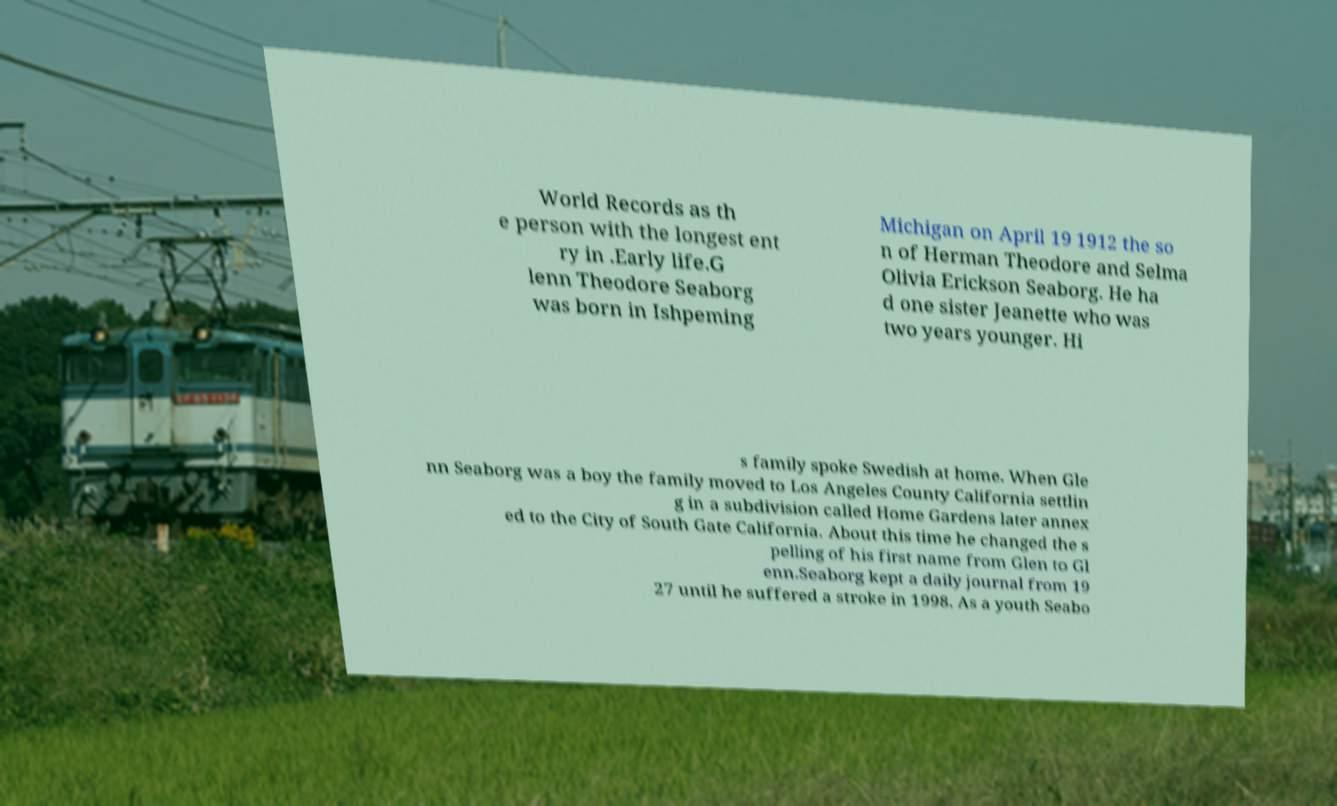What messages or text are displayed in this image? I need them in a readable, typed format. World Records as th e person with the longest ent ry in .Early life.G lenn Theodore Seaborg was born in Ishpeming Michigan on April 19 1912 the so n of Herman Theodore and Selma Olivia Erickson Seaborg. He ha d one sister Jeanette who was two years younger. Hi s family spoke Swedish at home. When Gle nn Seaborg was a boy the family moved to Los Angeles County California settlin g in a subdivision called Home Gardens later annex ed to the City of South Gate California. About this time he changed the s pelling of his first name from Glen to Gl enn.Seaborg kept a daily journal from 19 27 until he suffered a stroke in 1998. As a youth Seabo 